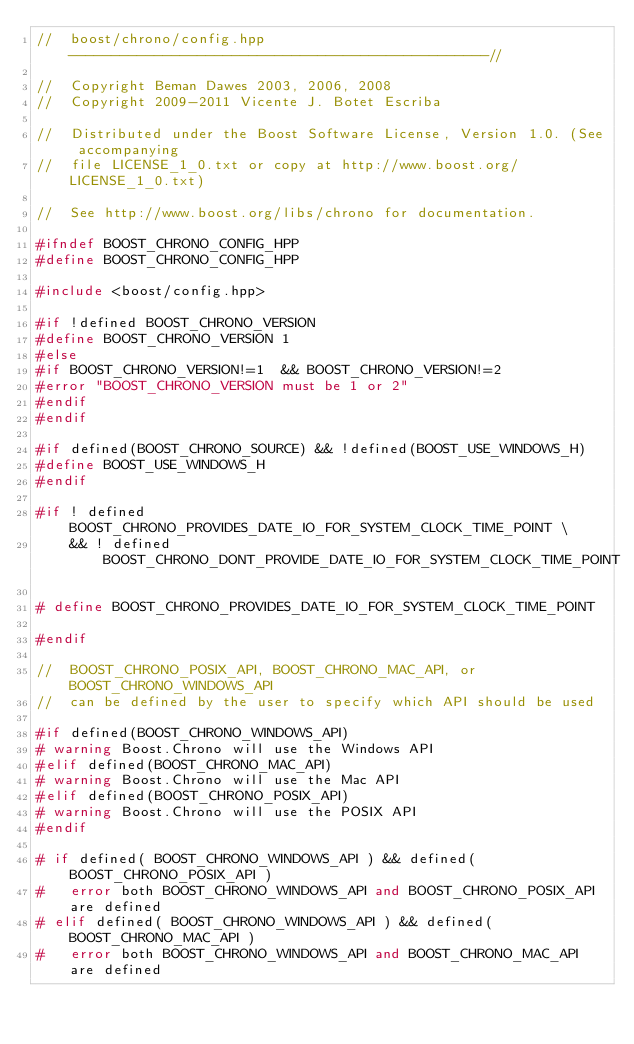<code> <loc_0><loc_0><loc_500><loc_500><_C++_>//  boost/chrono/config.hpp  -------------------------------------------------//

//  Copyright Beman Dawes 2003, 2006, 2008
//  Copyright 2009-2011 Vicente J. Botet Escriba

//  Distributed under the Boost Software License, Version 1.0. (See accompanying
//  file LICENSE_1_0.txt or copy at http://www.boost.org/LICENSE_1_0.txt)

//  See http://www.boost.org/libs/chrono for documentation.

#ifndef BOOST_CHRONO_CONFIG_HPP
#define BOOST_CHRONO_CONFIG_HPP

#include <boost/config.hpp>

#if !defined BOOST_CHRONO_VERSION
#define BOOST_CHRONO_VERSION 1
#else
#if BOOST_CHRONO_VERSION!=1  && BOOST_CHRONO_VERSION!=2
#error "BOOST_CHRONO_VERSION must be 1 or 2"
#endif
#endif

#if defined(BOOST_CHRONO_SOURCE) && !defined(BOOST_USE_WINDOWS_H)
#define BOOST_USE_WINDOWS_H
#endif

#if ! defined BOOST_CHRONO_PROVIDES_DATE_IO_FOR_SYSTEM_CLOCK_TIME_POINT \
    && ! defined BOOST_CHRONO_DONT_PROVIDE_DATE_IO_FOR_SYSTEM_CLOCK_TIME_POINT

# define BOOST_CHRONO_PROVIDES_DATE_IO_FOR_SYSTEM_CLOCK_TIME_POINT

#endif

//  BOOST_CHRONO_POSIX_API, BOOST_CHRONO_MAC_API, or BOOST_CHRONO_WINDOWS_API
//  can be defined by the user to specify which API should be used

#if defined(BOOST_CHRONO_WINDOWS_API)
# warning Boost.Chrono will use the Windows API
#elif defined(BOOST_CHRONO_MAC_API)
# warning Boost.Chrono will use the Mac API
#elif defined(BOOST_CHRONO_POSIX_API)
# warning Boost.Chrono will use the POSIX API
#endif

# if defined( BOOST_CHRONO_WINDOWS_API ) && defined( BOOST_CHRONO_POSIX_API )
#   error both BOOST_CHRONO_WINDOWS_API and BOOST_CHRONO_POSIX_API are defined
# elif defined( BOOST_CHRONO_WINDOWS_API ) && defined( BOOST_CHRONO_MAC_API )
#   error both BOOST_CHRONO_WINDOWS_API and BOOST_CHRONO_MAC_API are defined</code> 